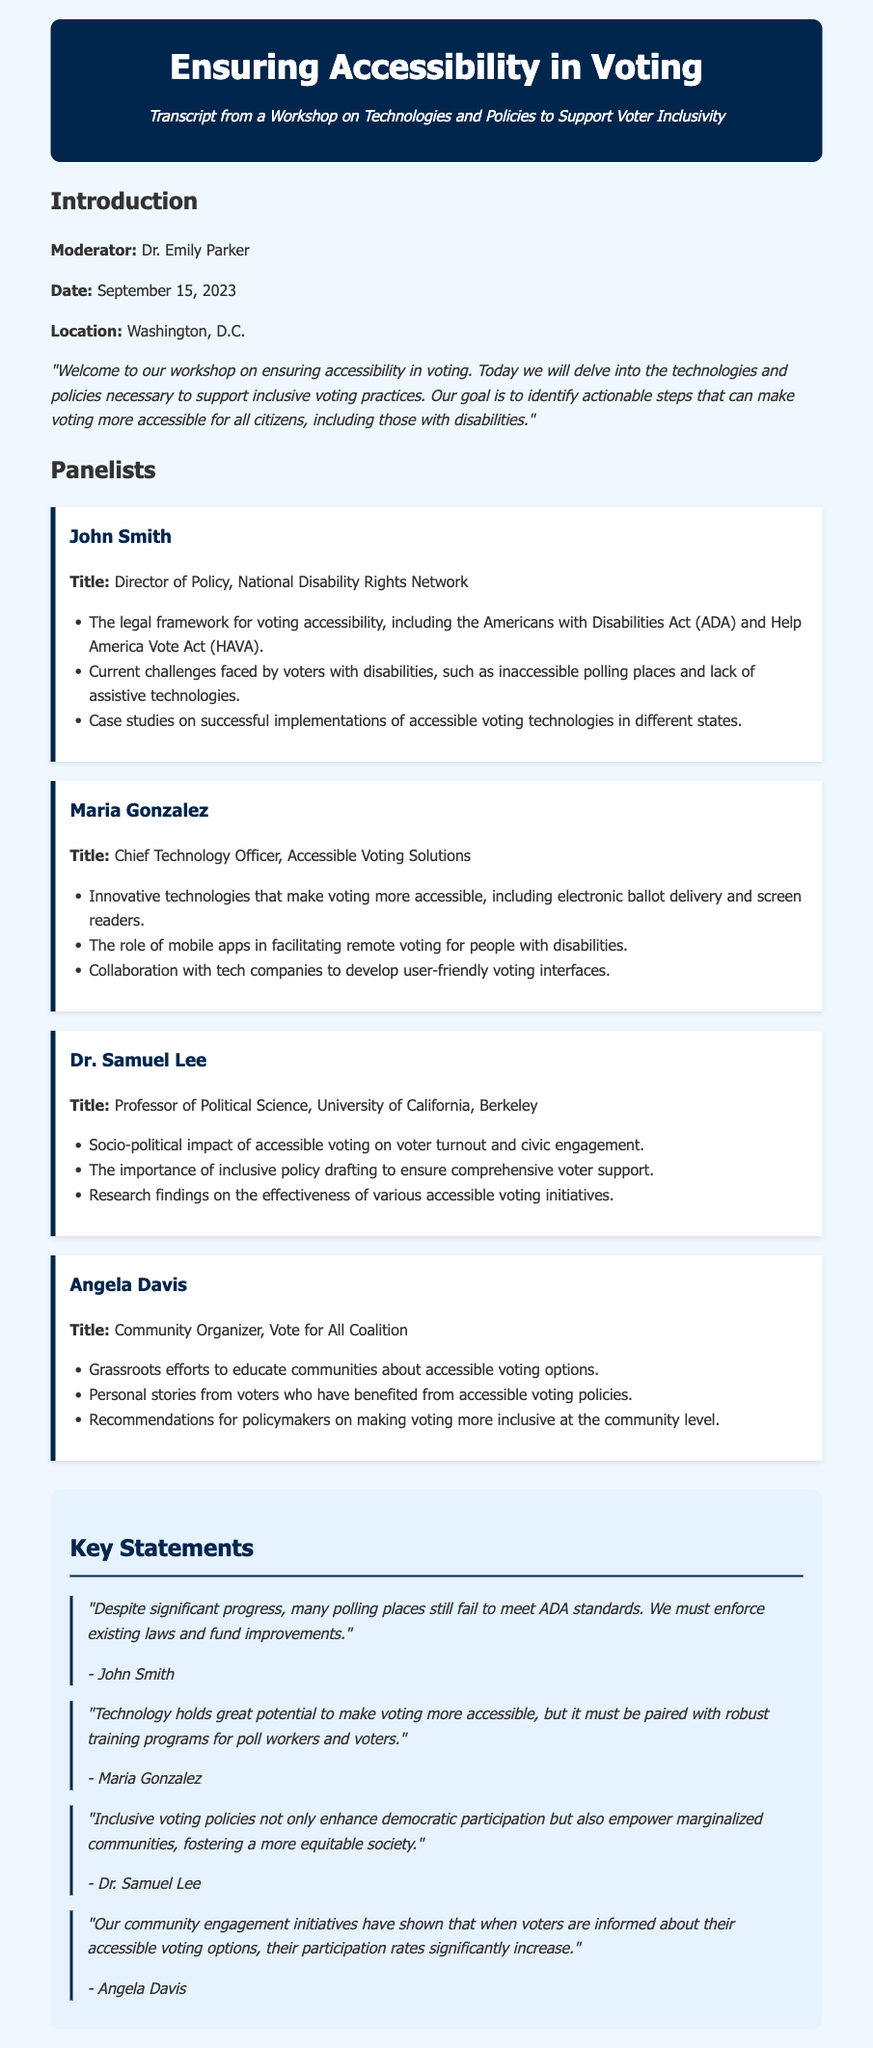What is the date of the workshop? The date is mentioned in the introduction section of the document.
Answer: September 15, 2023 Who is the moderator of the workshop? The moderator is identified at the beginning of the document.
Answer: Dr. Emily Parker What organization does John Smith represent? John Smith's title and organization are stated in the panelists section.
Answer: National Disability Rights Network What technology is highlighted for facilitating remote voting? Maria Gonzalez discusses the role of a specific technology in her panelist section.
Answer: Mobile apps Which act is mentioned alongside the ADA? The legal framework for voting accessibility includes specific acts referred to in the panelists' summaries.
Answer: Help America Vote Act (HAVA) What was the impact of community engagement initiatives according to Angela Davis? Angela Davis shares insights on community engagement in her panelist section.
Answer: Participation rates significantly increase What is a significant challenge mentioned by John Smith regarding polling places? John Smith highlights specific challenges related to polling places in his statements.
Answer: Fail to meet ADA standards Why is training programs for poll workers necessary according to Maria Gonzalez? The necessity of training programs is emphasized in her statement about technology.
Answer: Must be paired with robust training programs What is the focus of Dr. Samuel Lee's research findings? Dr. Samuel Lee’s contributions in the document indicate the subject of his research findings.
Answer: Effectiveness of various accessible voting initiatives 